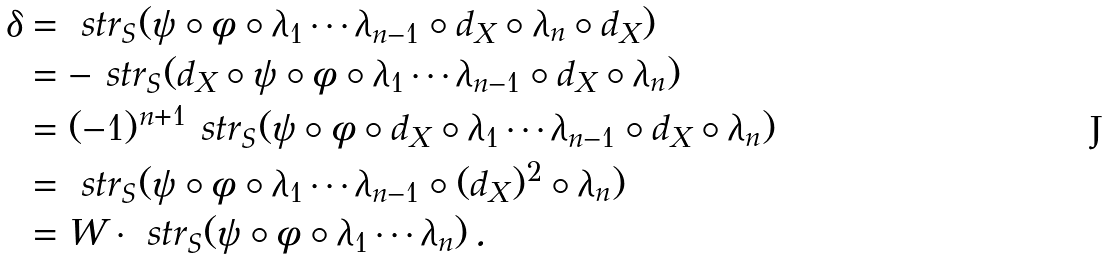Convert formula to latex. <formula><loc_0><loc_0><loc_500><loc_500>\delta & = \ s t r _ { S } ( \psi \circ \phi \circ \lambda _ { 1 } \cdots \lambda _ { n - 1 } \circ d _ { X } \circ \lambda _ { n } \circ d _ { X } ) \\ & = - \ s t r _ { S } ( d _ { X } \circ \psi \circ \phi \circ \lambda _ { 1 } \cdots \lambda _ { n - 1 } \circ d _ { X } \circ \lambda _ { n } ) \\ & = ( - 1 ) ^ { n + 1 } \ s t r _ { S } ( \psi \circ \phi \circ d _ { X } \circ \lambda _ { 1 } \cdots \lambda _ { n - 1 } \circ d _ { X } \circ \lambda _ { n } ) \\ & = \ s t r _ { S } ( \psi \circ \phi \circ \lambda _ { 1 } \cdots \lambda _ { n - 1 } \circ ( d _ { X } ) ^ { 2 } \circ \lambda _ { n } ) \\ & = W \cdot \ s t r _ { S } ( \psi \circ \phi \circ \lambda _ { 1 } \cdots \lambda _ { n } ) \, .</formula> 